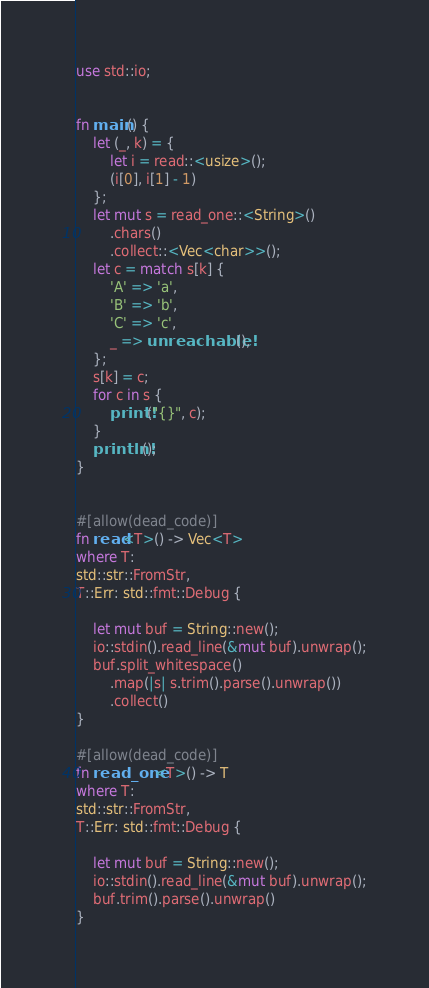Convert code to text. <code><loc_0><loc_0><loc_500><loc_500><_Rust_>use std::io;


fn main() {
    let (_, k) = {
        let i = read::<usize>();
        (i[0], i[1] - 1)
    };
    let mut s = read_one::<String>()
        .chars()
        .collect::<Vec<char>>();
    let c = match s[k] {
        'A' => 'a',
        'B' => 'b',
        'C' => 'c',
        _ => unreachable!(),
    };
    s[k] = c;
    for c in s {
        print!("{}", c);
    }
    println!();
}


#[allow(dead_code)]
fn read<T>() -> Vec<T>
where T:
std::str::FromStr,
T::Err: std::fmt::Debug {

    let mut buf = String::new();
    io::stdin().read_line(&mut buf).unwrap();
    buf.split_whitespace()
        .map(|s| s.trim().parse().unwrap())
        .collect()
}

#[allow(dead_code)]
fn read_one<T>() -> T
where T:
std::str::FromStr,
T::Err: std::fmt::Debug {

    let mut buf = String::new();
    io::stdin().read_line(&mut buf).unwrap();
    buf.trim().parse().unwrap()
}</code> 